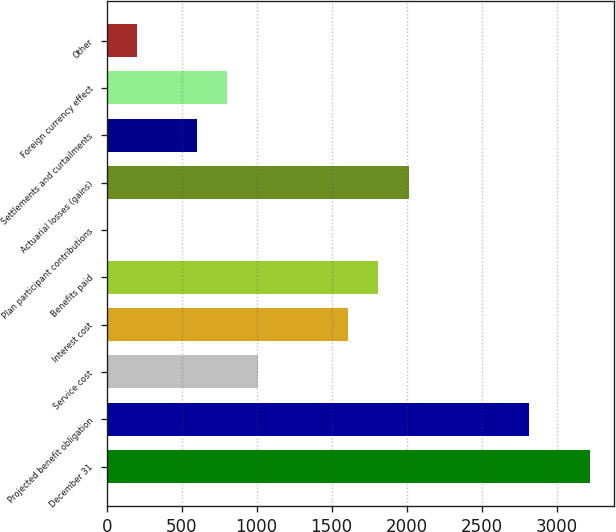Convert chart to OTSL. <chart><loc_0><loc_0><loc_500><loc_500><bar_chart><fcel>December 31<fcel>Projected benefit obligation<fcel>Service cost<fcel>Interest cost<fcel>Benefits paid<fcel>Plan participant contributions<fcel>Actuarial losses (gains)<fcel>Settlements and curtailments<fcel>Foreign currency effect<fcel>Other<nl><fcel>3220.5<fcel>2818<fcel>1006.75<fcel>1610.5<fcel>1811.75<fcel>0.5<fcel>2013<fcel>604.25<fcel>805.5<fcel>201.75<nl></chart> 